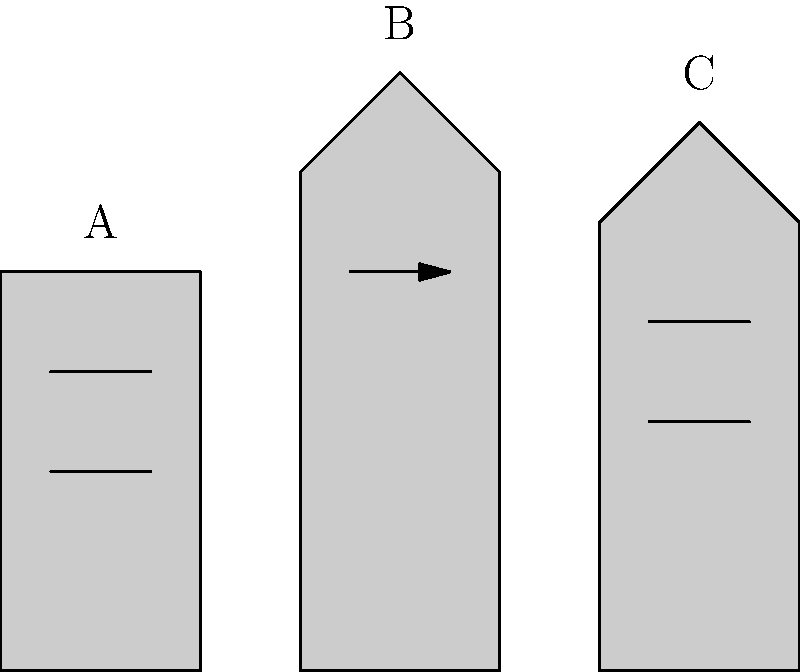As an amateur historian with an interest in physics, you're analyzing the facade images of three historical buildings labeled A, B, and C. Based on the architectural features shown, which building is most likely to represent the Gothic style? To determine which building is most likely to represent the Gothic style, let's analyze the key features of each building:

1. Building A:
   - Rectangular shape
   - Simple, flat roof
   - Horizontal lines (windows)
   - No visible ornate details

2. Building B:
   - Pointed roof
   - Vertical emphasis
   - Presence of a spire or tower-like structure
   - Arched window or entrance (indicated by the arrow)

3. Building C:
   - Slightly pointed roof
   - Rectangular shape
   - Horizontal lines (windows)
   - No visible ornate details

Gothic architecture is characterized by:
- Pointed arches
- Ribbed vaults
- Flying buttresses
- Tall spires
- Emphasis on verticality
- Large windows

Among the three buildings, Building B exhibits the most Gothic characteristics:
1. The pointed roof aligns with the Gothic emphasis on verticality.
2. The presence of a spire or tower-like structure is a common Gothic feature.
3. The arched window or entrance (indicated by the arrow) could represent a pointed arch, which is a hallmark of Gothic architecture.

Buildings A and C lack the distinctive features of Gothic architecture, appearing more simplistic and rectilinear in design.
Answer: B 